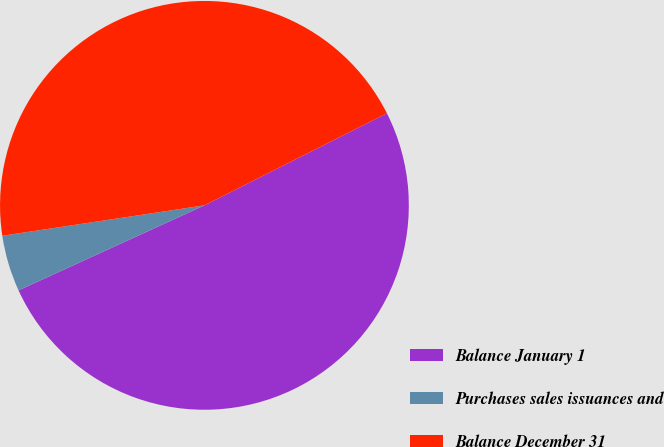Convert chart. <chart><loc_0><loc_0><loc_500><loc_500><pie_chart><fcel>Balance January 1<fcel>Purchases sales issuances and<fcel>Balance December 31<nl><fcel>50.61%<fcel>4.45%<fcel>44.94%<nl></chart> 